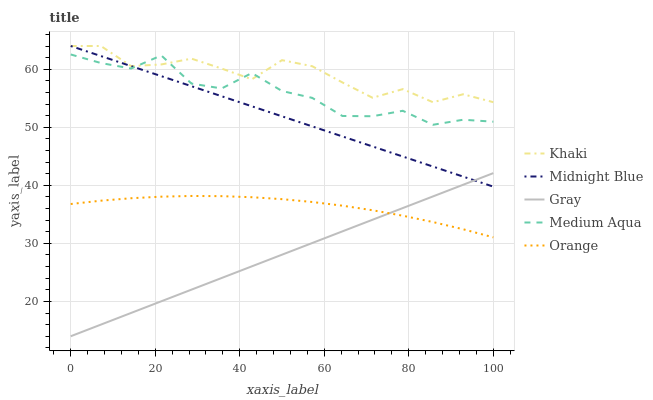Does Gray have the minimum area under the curve?
Answer yes or no. Yes. Does Khaki have the maximum area under the curve?
Answer yes or no. Yes. Does Khaki have the minimum area under the curve?
Answer yes or no. No. Does Gray have the maximum area under the curve?
Answer yes or no. No. Is Gray the smoothest?
Answer yes or no. Yes. Is Medium Aqua the roughest?
Answer yes or no. Yes. Is Khaki the smoothest?
Answer yes or no. No. Is Khaki the roughest?
Answer yes or no. No. Does Gray have the lowest value?
Answer yes or no. Yes. Does Khaki have the lowest value?
Answer yes or no. No. Does Midnight Blue have the highest value?
Answer yes or no. Yes. Does Gray have the highest value?
Answer yes or no. No. Is Orange less than Khaki?
Answer yes or no. Yes. Is Khaki greater than Orange?
Answer yes or no. Yes. Does Gray intersect Orange?
Answer yes or no. Yes. Is Gray less than Orange?
Answer yes or no. No. Is Gray greater than Orange?
Answer yes or no. No. Does Orange intersect Khaki?
Answer yes or no. No. 